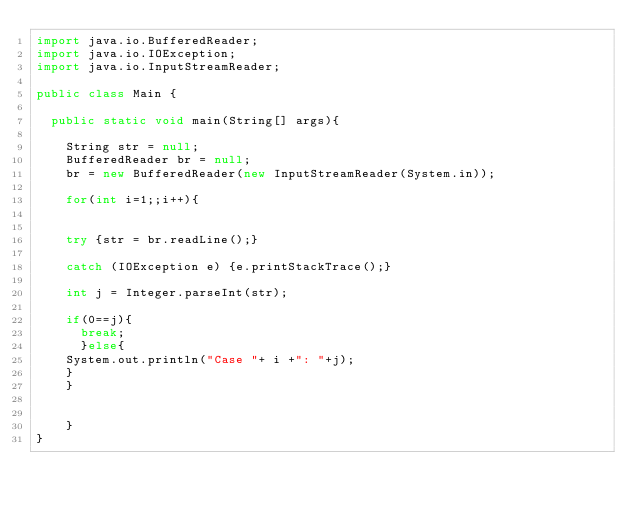<code> <loc_0><loc_0><loc_500><loc_500><_Java_>import java.io.BufferedReader;
import java.io.IOException;
import java.io.InputStreamReader;

public class Main {

	public static void main(String[] args){

		String str = null;
		BufferedReader br = null;
		br = new BufferedReader(new InputStreamReader(System.in));
		
		for(int i=1;;i++){
			
		
		try {str = br.readLine();} 
		
		catch (IOException e) {e.printStackTrace();}
		
		int j = Integer.parseInt(str);
		
		if(0==j){
			break;
			}else{
		System.out.println("Case "+ i +": "+j);
		}
		}
		
		
		}
}</code> 